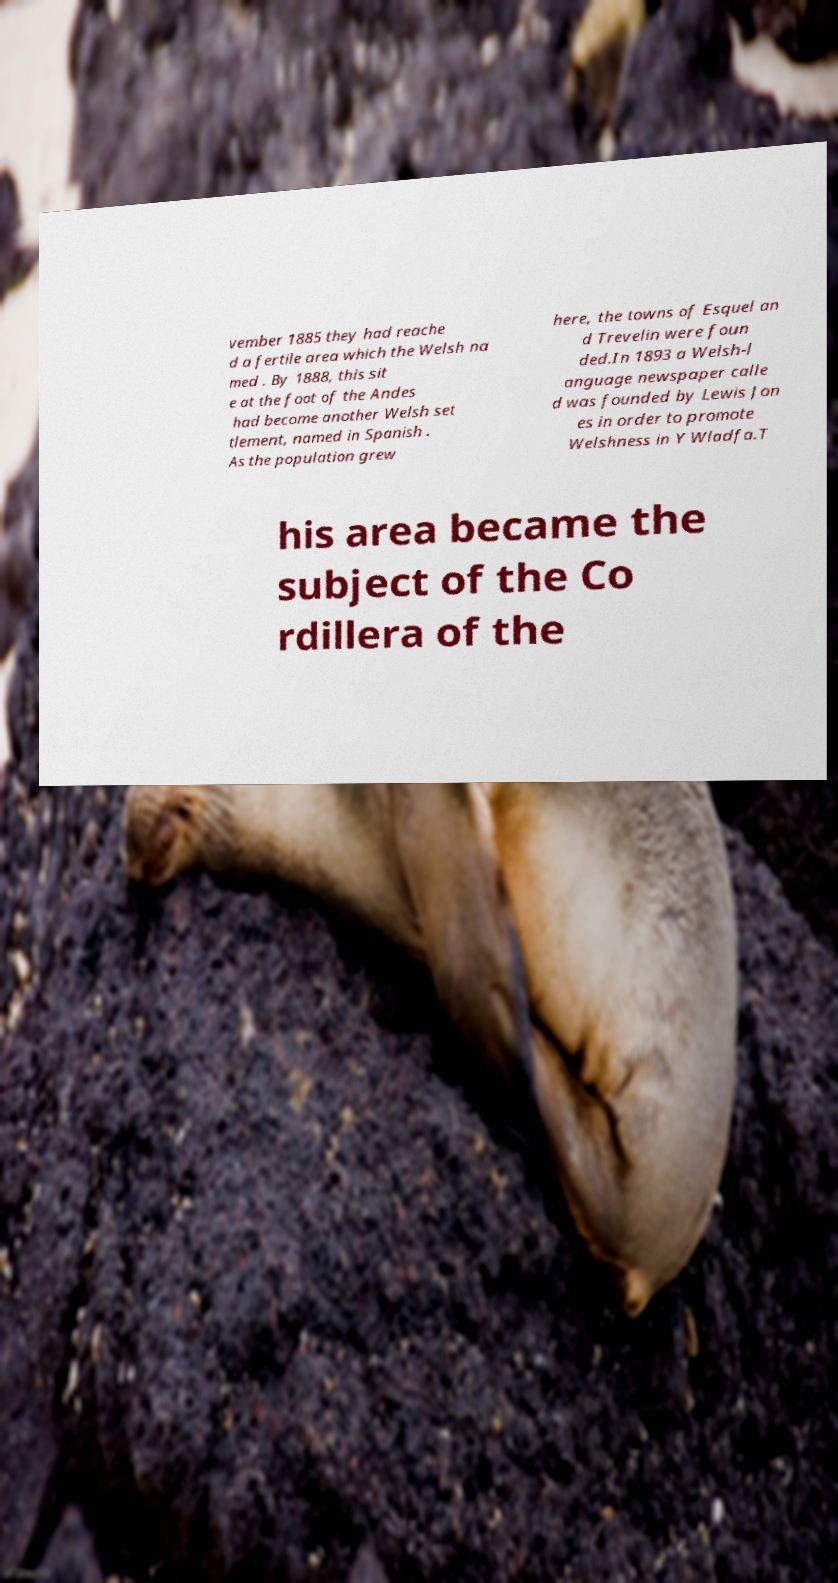For documentation purposes, I need the text within this image transcribed. Could you provide that? vember 1885 they had reache d a fertile area which the Welsh na med . By 1888, this sit e at the foot of the Andes had become another Welsh set tlement, named in Spanish . As the population grew here, the towns of Esquel an d Trevelin were foun ded.In 1893 a Welsh-l anguage newspaper calle d was founded by Lewis Jon es in order to promote Welshness in Y Wladfa.T his area became the subject of the Co rdillera of the 